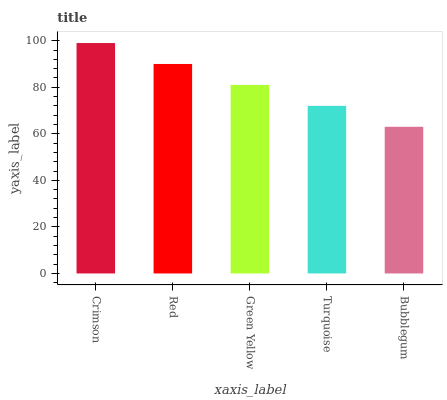Is Bubblegum the minimum?
Answer yes or no. Yes. Is Crimson the maximum?
Answer yes or no. Yes. Is Red the minimum?
Answer yes or no. No. Is Red the maximum?
Answer yes or no. No. Is Crimson greater than Red?
Answer yes or no. Yes. Is Red less than Crimson?
Answer yes or no. Yes. Is Red greater than Crimson?
Answer yes or no. No. Is Crimson less than Red?
Answer yes or no. No. Is Green Yellow the high median?
Answer yes or no. Yes. Is Green Yellow the low median?
Answer yes or no. Yes. Is Red the high median?
Answer yes or no. No. Is Crimson the low median?
Answer yes or no. No. 